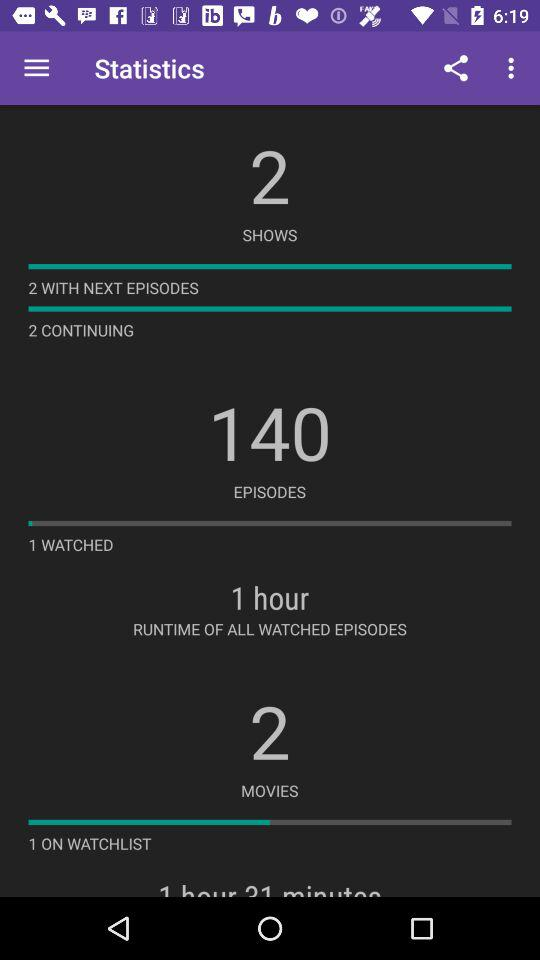How many shows are continuing? There are 2 shows that are continuing. 